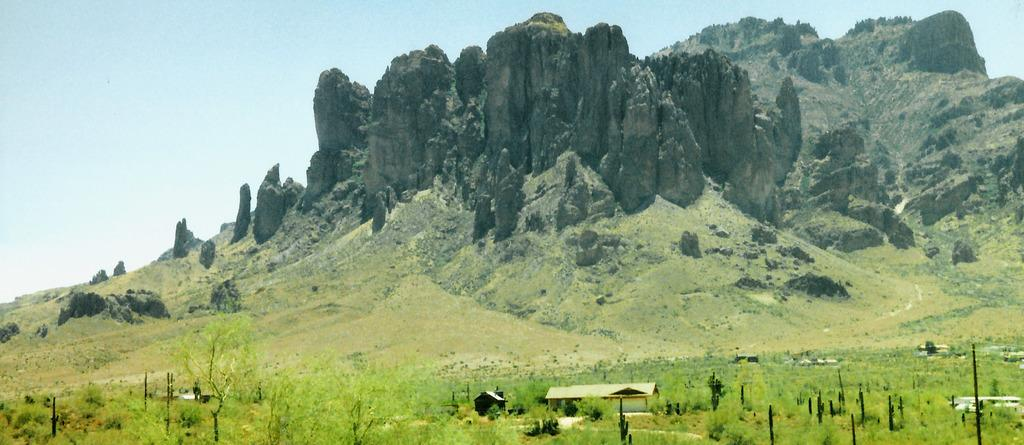What type of ground covering is visible in the image? The ground in the image is covered with grass. What type of vegetation is present in the image? There are many trees in the image. What type of structures can be seen in the image? There are buildings in the image. What type of natural formation is visible in the background of the image? Rock hills are visible in the background of the image. What type of cloth is draped over the rock hills in the image? There is no cloth draped over the rock hills in the image; they are visible in their natural state. 